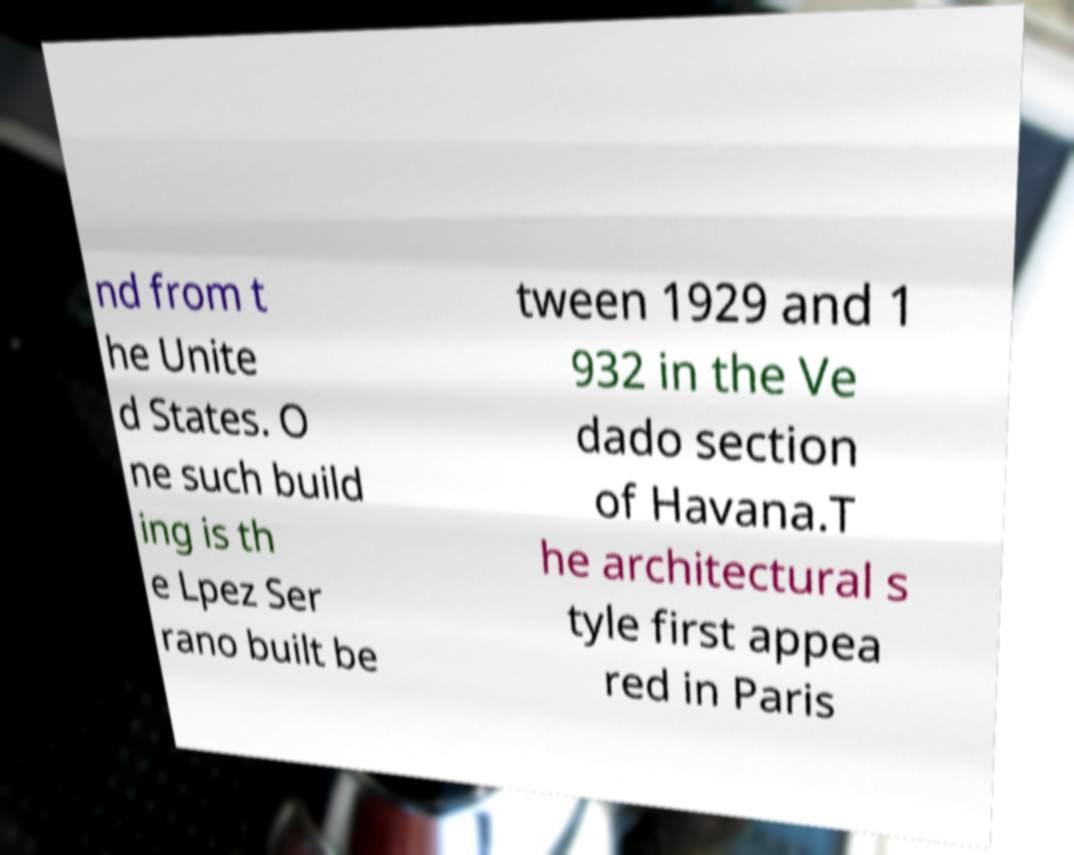Can you accurately transcribe the text from the provided image for me? nd from t he Unite d States. O ne such build ing is th e Lpez Ser rano built be tween 1929 and 1 932 in the Ve dado section of Havana.T he architectural s tyle first appea red in Paris 